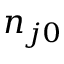Convert formula to latex. <formula><loc_0><loc_0><loc_500><loc_500>n _ { j 0 }</formula> 